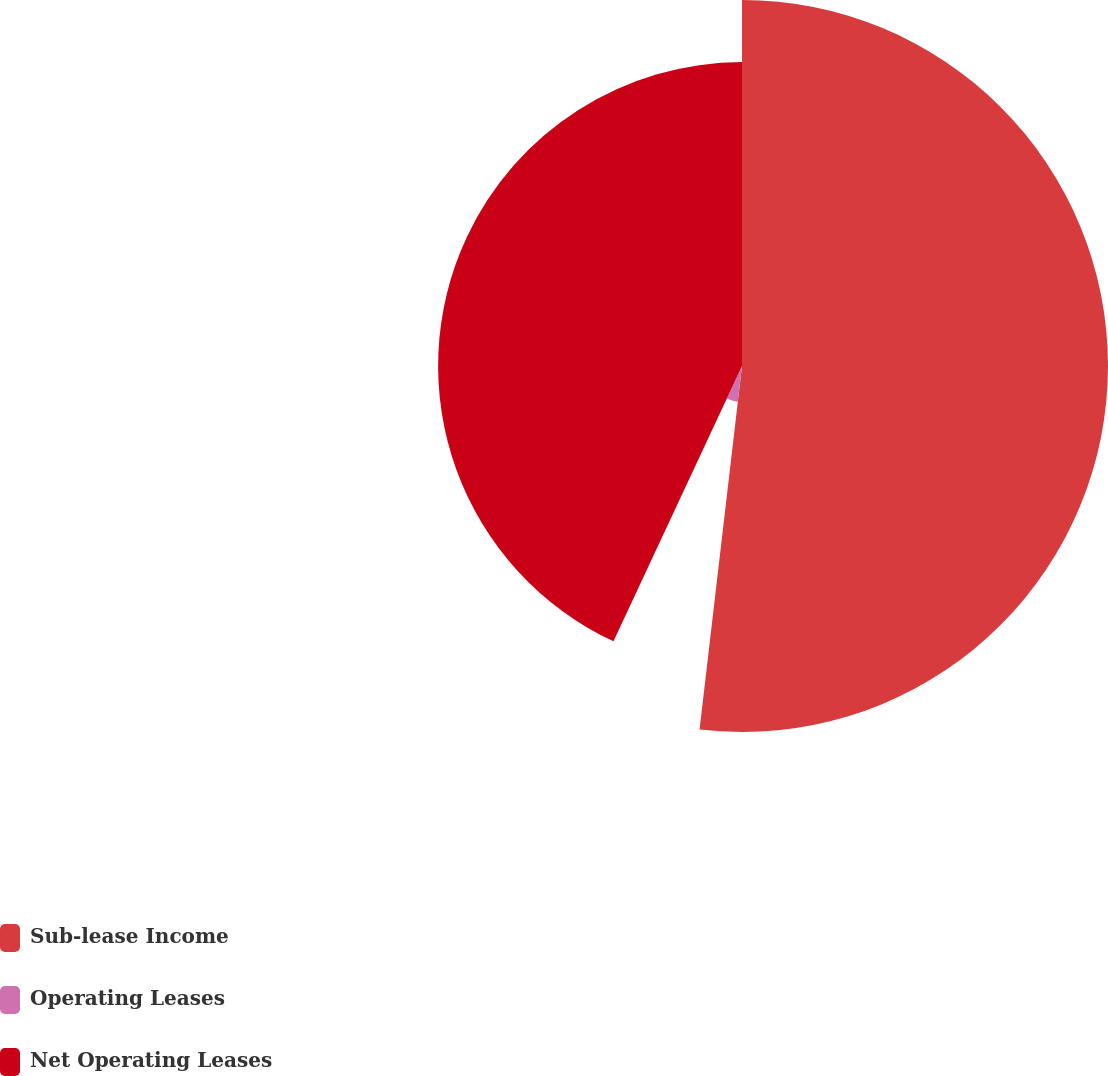<chart> <loc_0><loc_0><loc_500><loc_500><pie_chart><fcel>Sub-lease Income<fcel>Operating Leases<fcel>Net Operating Leases<nl><fcel>51.85%<fcel>5.1%<fcel>43.05%<nl></chart> 